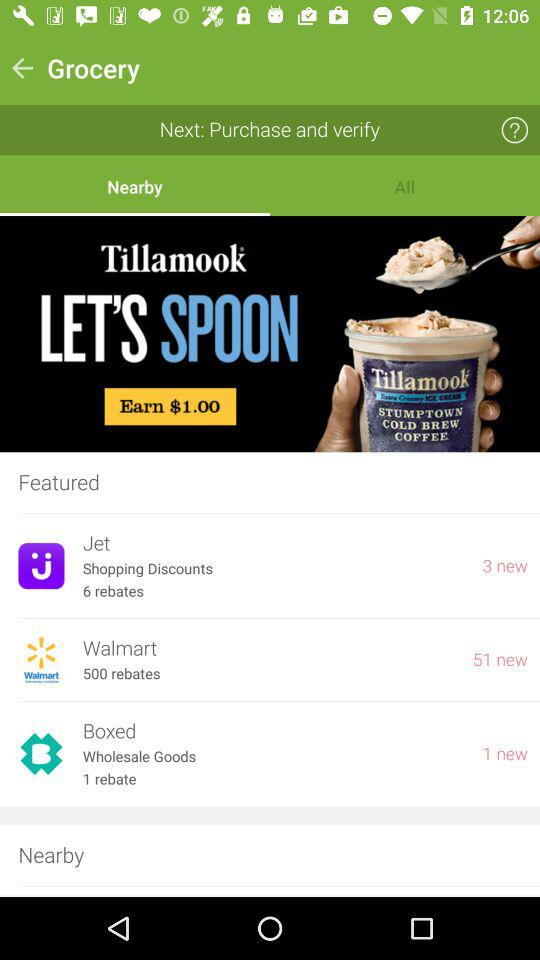Which retail company has 51 new rebates? The retail company that has 51 new rebates is Walmart. 